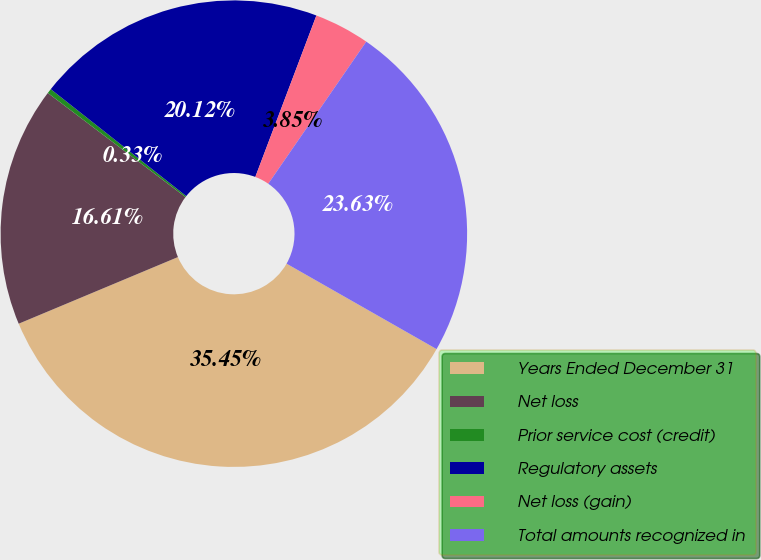Convert chart. <chart><loc_0><loc_0><loc_500><loc_500><pie_chart><fcel>Years Ended December 31<fcel>Net loss<fcel>Prior service cost (credit)<fcel>Regulatory assets<fcel>Net loss (gain)<fcel>Total amounts recognized in<nl><fcel>35.45%<fcel>16.61%<fcel>0.33%<fcel>20.12%<fcel>3.85%<fcel>23.63%<nl></chart> 